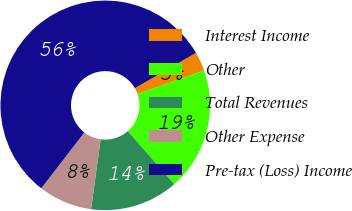Convert chart to OTSL. <chart><loc_0><loc_0><loc_500><loc_500><pie_chart><fcel>Interest Income<fcel>Other<fcel>Total Revenues<fcel>Other Expense<fcel>Pre-tax (Loss) Income<nl><fcel>2.96%<fcel>18.94%<fcel>13.61%<fcel>8.29%<fcel>56.2%<nl></chart> 